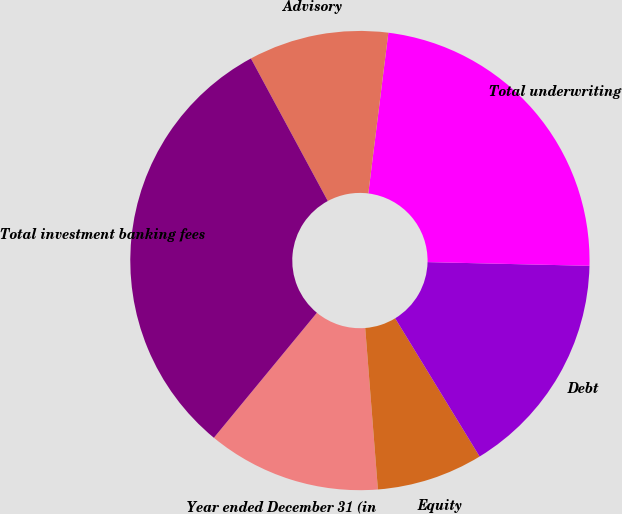Convert chart to OTSL. <chart><loc_0><loc_0><loc_500><loc_500><pie_chart><fcel>Year ended December 31 (in<fcel>Equity<fcel>Debt<fcel>Total underwriting<fcel>Advisory<fcel>Total investment banking fees<nl><fcel>12.22%<fcel>7.48%<fcel>15.91%<fcel>23.39%<fcel>9.85%<fcel>31.16%<nl></chart> 